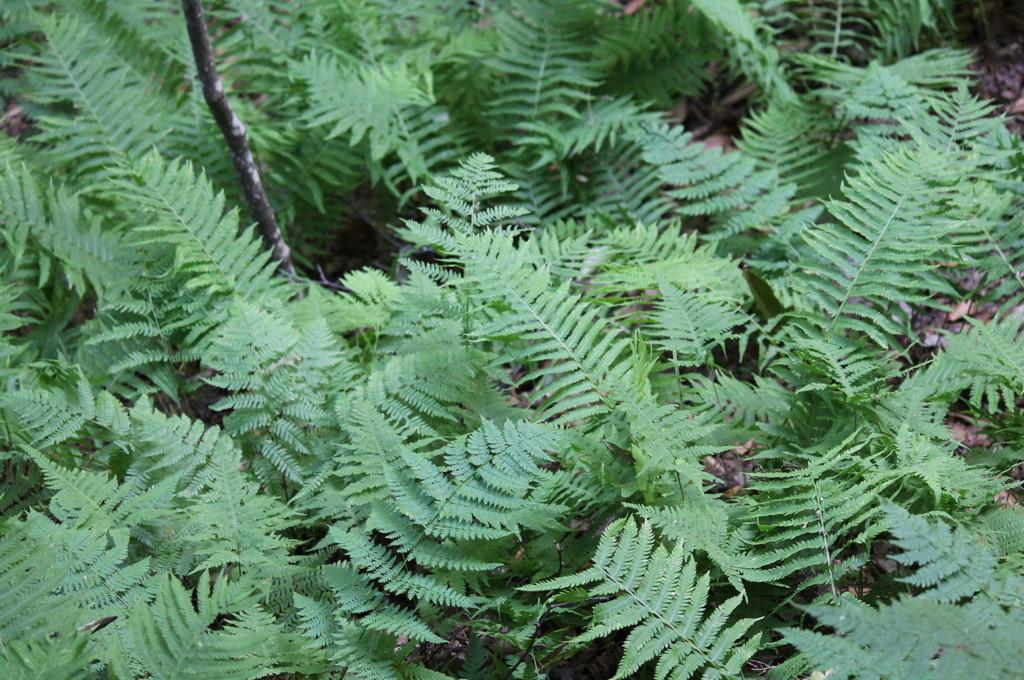What type of vegetation is visible in the image? The image contains many trees and plants. Can you describe the setting in which the trees and plants are located? The setting appears to be a forest. What type of lettuce can be seen growing among the trees in the image? There is no lettuce present in the image; it features trees and plants in a forest setting. 